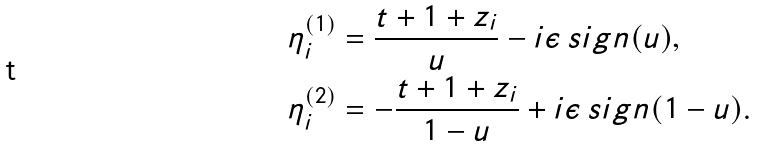<formula> <loc_0><loc_0><loc_500><loc_500>\eta _ { i } ^ { ( 1 ) } & = \frac { t + 1 + z _ { i } } { u } - i \epsilon \, s i g n ( u ) , \\ \eta _ { i } ^ { ( 2 ) } & = - \frac { t + 1 + z _ { i } } { 1 - u } + i \epsilon \, s i g n ( 1 - u ) .</formula> 